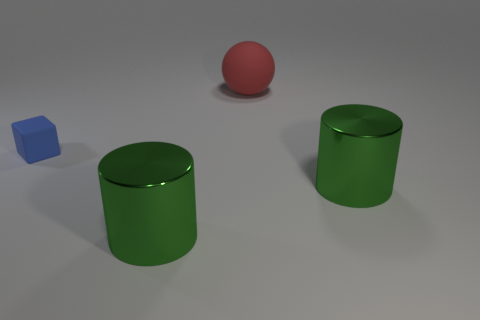How many gray metal cubes are there?
Provide a succinct answer. 0. Is the shape of the big red object the same as the large green metallic object that is on the left side of the red matte object?
Your answer should be compact. No. How many objects are either big red objects or tiny cubes?
Your answer should be compact. 2. What shape is the small object behind the large green shiny cylinder to the right of the rubber ball?
Your response must be concise. Cube. Is the shape of the shiny thing to the left of the big ball the same as  the blue matte object?
Your response must be concise. No. What size is the blue cube that is the same material as the red sphere?
Make the answer very short. Small. How many objects are either things that are in front of the red thing or cylinders that are right of the blue matte cube?
Offer a very short reply. 3. Are there the same number of big green shiny objects that are behind the ball and big green objects that are on the left side of the small blue thing?
Give a very brief answer. Yes. There is a rubber thing on the right side of the blue rubber thing; what is its color?
Ensure brevity in your answer.  Red. There is a large rubber object; is it the same color as the rubber object that is on the left side of the big matte ball?
Provide a short and direct response. No. 